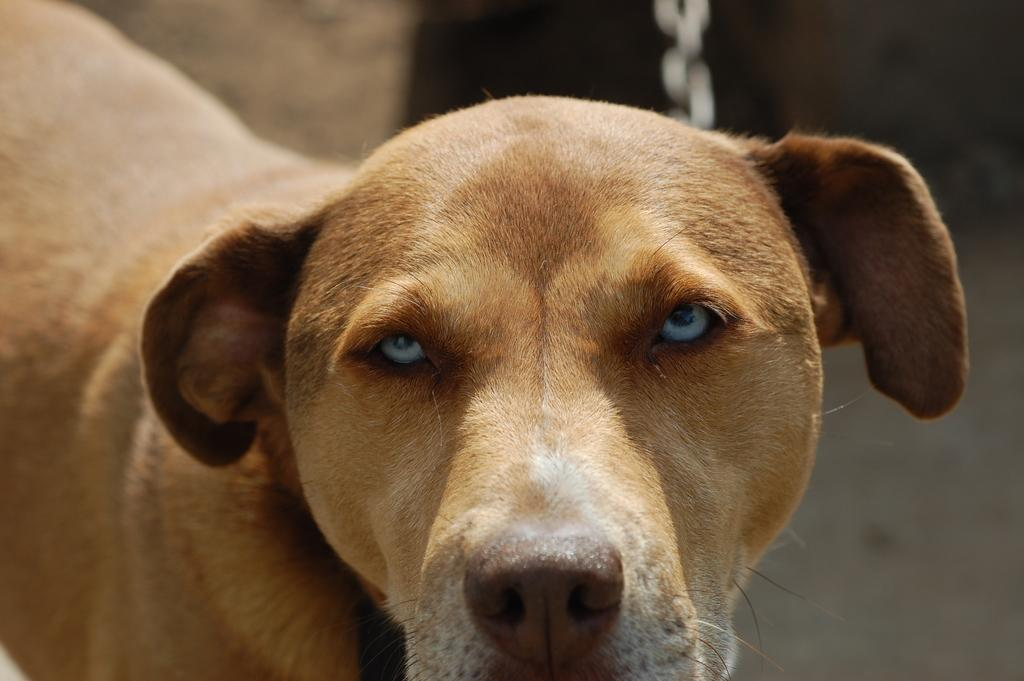What type of animal is in the image? There is a dog in the image. Can you describe the quality of the image? The top part of the image is blurred. What flavor of card can be seen in the image? There is no card or flavor mentioned in the image; it features a dog and a blurred top part. 